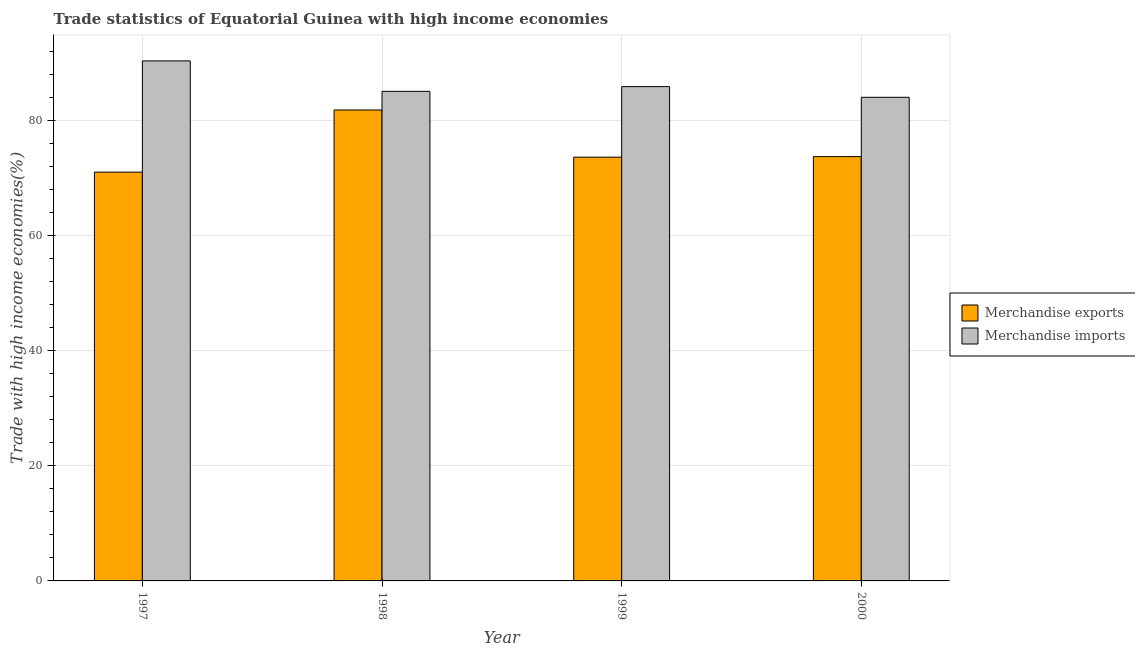How many different coloured bars are there?
Make the answer very short. 2. How many groups of bars are there?
Make the answer very short. 4. Are the number of bars per tick equal to the number of legend labels?
Offer a very short reply. Yes. Are the number of bars on each tick of the X-axis equal?
Provide a short and direct response. Yes. How many bars are there on the 1st tick from the right?
Offer a terse response. 2. What is the label of the 1st group of bars from the left?
Your answer should be very brief. 1997. In how many cases, is the number of bars for a given year not equal to the number of legend labels?
Provide a short and direct response. 0. What is the merchandise imports in 1997?
Your answer should be very brief. 90.31. Across all years, what is the maximum merchandise imports?
Ensure brevity in your answer.  90.31. Across all years, what is the minimum merchandise imports?
Offer a terse response. 83.98. In which year was the merchandise exports minimum?
Keep it short and to the point. 1997. What is the total merchandise exports in the graph?
Provide a succinct answer. 300.03. What is the difference between the merchandise imports in 1997 and that in 1998?
Give a very brief answer. 5.29. What is the difference between the merchandise exports in 1999 and the merchandise imports in 1998?
Your answer should be compact. -8.19. What is the average merchandise imports per year?
Your answer should be very brief. 86.29. What is the ratio of the merchandise exports in 1997 to that in 1998?
Make the answer very short. 0.87. Is the merchandise exports in 1998 less than that in 1999?
Make the answer very short. No. What is the difference between the highest and the second highest merchandise imports?
Give a very brief answer. 4.47. What is the difference between the highest and the lowest merchandise exports?
Your response must be concise. 10.79. What does the 1st bar from the left in 1999 represents?
Give a very brief answer. Merchandise exports. What is the difference between two consecutive major ticks on the Y-axis?
Keep it short and to the point. 20. Are the values on the major ticks of Y-axis written in scientific E-notation?
Your response must be concise. No. Where does the legend appear in the graph?
Provide a short and direct response. Center right. How are the legend labels stacked?
Give a very brief answer. Vertical. What is the title of the graph?
Keep it short and to the point. Trade statistics of Equatorial Guinea with high income economies. Does "Travel services" appear as one of the legend labels in the graph?
Your response must be concise. No. What is the label or title of the X-axis?
Provide a short and direct response. Year. What is the label or title of the Y-axis?
Your response must be concise. Trade with high income economies(%). What is the Trade with high income economies(%) of Merchandise exports in 1997?
Ensure brevity in your answer.  70.98. What is the Trade with high income economies(%) of Merchandise imports in 1997?
Keep it short and to the point. 90.31. What is the Trade with high income economies(%) in Merchandise exports in 1998?
Ensure brevity in your answer.  81.78. What is the Trade with high income economies(%) in Merchandise imports in 1998?
Keep it short and to the point. 85.02. What is the Trade with high income economies(%) in Merchandise exports in 1999?
Offer a terse response. 73.59. What is the Trade with high income economies(%) of Merchandise imports in 1999?
Keep it short and to the point. 85.84. What is the Trade with high income economies(%) of Merchandise exports in 2000?
Your response must be concise. 73.68. What is the Trade with high income economies(%) in Merchandise imports in 2000?
Your response must be concise. 83.98. Across all years, what is the maximum Trade with high income economies(%) in Merchandise exports?
Your answer should be compact. 81.78. Across all years, what is the maximum Trade with high income economies(%) in Merchandise imports?
Provide a succinct answer. 90.31. Across all years, what is the minimum Trade with high income economies(%) of Merchandise exports?
Your answer should be very brief. 70.98. Across all years, what is the minimum Trade with high income economies(%) of Merchandise imports?
Offer a terse response. 83.98. What is the total Trade with high income economies(%) in Merchandise exports in the graph?
Offer a terse response. 300.03. What is the total Trade with high income economies(%) in Merchandise imports in the graph?
Your answer should be compact. 345.14. What is the difference between the Trade with high income economies(%) in Merchandise exports in 1997 and that in 1998?
Provide a short and direct response. -10.79. What is the difference between the Trade with high income economies(%) of Merchandise imports in 1997 and that in 1998?
Your response must be concise. 5.29. What is the difference between the Trade with high income economies(%) of Merchandise exports in 1997 and that in 1999?
Give a very brief answer. -2.6. What is the difference between the Trade with high income economies(%) in Merchandise imports in 1997 and that in 1999?
Your answer should be compact. 4.47. What is the difference between the Trade with high income economies(%) of Merchandise exports in 1997 and that in 2000?
Offer a very short reply. -2.69. What is the difference between the Trade with high income economies(%) of Merchandise imports in 1997 and that in 2000?
Provide a succinct answer. 6.33. What is the difference between the Trade with high income economies(%) in Merchandise exports in 1998 and that in 1999?
Give a very brief answer. 8.19. What is the difference between the Trade with high income economies(%) of Merchandise imports in 1998 and that in 1999?
Provide a succinct answer. -0.82. What is the difference between the Trade with high income economies(%) in Merchandise exports in 1998 and that in 2000?
Offer a terse response. 8.1. What is the difference between the Trade with high income economies(%) of Merchandise imports in 1998 and that in 2000?
Give a very brief answer. 1.04. What is the difference between the Trade with high income economies(%) of Merchandise exports in 1999 and that in 2000?
Provide a short and direct response. -0.09. What is the difference between the Trade with high income economies(%) of Merchandise imports in 1999 and that in 2000?
Your response must be concise. 1.86. What is the difference between the Trade with high income economies(%) in Merchandise exports in 1997 and the Trade with high income economies(%) in Merchandise imports in 1998?
Provide a succinct answer. -14.03. What is the difference between the Trade with high income economies(%) in Merchandise exports in 1997 and the Trade with high income economies(%) in Merchandise imports in 1999?
Ensure brevity in your answer.  -14.85. What is the difference between the Trade with high income economies(%) of Merchandise exports in 1997 and the Trade with high income economies(%) of Merchandise imports in 2000?
Give a very brief answer. -13. What is the difference between the Trade with high income economies(%) in Merchandise exports in 1998 and the Trade with high income economies(%) in Merchandise imports in 1999?
Provide a succinct answer. -4.06. What is the difference between the Trade with high income economies(%) of Merchandise exports in 1998 and the Trade with high income economies(%) of Merchandise imports in 2000?
Your answer should be compact. -2.2. What is the difference between the Trade with high income economies(%) of Merchandise exports in 1999 and the Trade with high income economies(%) of Merchandise imports in 2000?
Provide a short and direct response. -10.39. What is the average Trade with high income economies(%) of Merchandise exports per year?
Your answer should be very brief. 75.01. What is the average Trade with high income economies(%) in Merchandise imports per year?
Your response must be concise. 86.29. In the year 1997, what is the difference between the Trade with high income economies(%) of Merchandise exports and Trade with high income economies(%) of Merchandise imports?
Your answer should be very brief. -19.32. In the year 1998, what is the difference between the Trade with high income economies(%) of Merchandise exports and Trade with high income economies(%) of Merchandise imports?
Keep it short and to the point. -3.24. In the year 1999, what is the difference between the Trade with high income economies(%) of Merchandise exports and Trade with high income economies(%) of Merchandise imports?
Your response must be concise. -12.25. In the year 2000, what is the difference between the Trade with high income economies(%) of Merchandise exports and Trade with high income economies(%) of Merchandise imports?
Ensure brevity in your answer.  -10.3. What is the ratio of the Trade with high income economies(%) of Merchandise exports in 1997 to that in 1998?
Offer a terse response. 0.87. What is the ratio of the Trade with high income economies(%) of Merchandise imports in 1997 to that in 1998?
Offer a very short reply. 1.06. What is the ratio of the Trade with high income economies(%) in Merchandise exports in 1997 to that in 1999?
Give a very brief answer. 0.96. What is the ratio of the Trade with high income economies(%) of Merchandise imports in 1997 to that in 1999?
Give a very brief answer. 1.05. What is the ratio of the Trade with high income economies(%) in Merchandise exports in 1997 to that in 2000?
Your answer should be very brief. 0.96. What is the ratio of the Trade with high income economies(%) of Merchandise imports in 1997 to that in 2000?
Ensure brevity in your answer.  1.08. What is the ratio of the Trade with high income economies(%) in Merchandise exports in 1998 to that in 1999?
Ensure brevity in your answer.  1.11. What is the ratio of the Trade with high income economies(%) in Merchandise exports in 1998 to that in 2000?
Your answer should be very brief. 1.11. What is the ratio of the Trade with high income economies(%) in Merchandise imports in 1998 to that in 2000?
Your response must be concise. 1.01. What is the ratio of the Trade with high income economies(%) in Merchandise exports in 1999 to that in 2000?
Your answer should be compact. 1. What is the ratio of the Trade with high income economies(%) of Merchandise imports in 1999 to that in 2000?
Your answer should be compact. 1.02. What is the difference between the highest and the second highest Trade with high income economies(%) of Merchandise imports?
Make the answer very short. 4.47. What is the difference between the highest and the lowest Trade with high income economies(%) of Merchandise exports?
Offer a very short reply. 10.79. What is the difference between the highest and the lowest Trade with high income economies(%) of Merchandise imports?
Offer a very short reply. 6.33. 